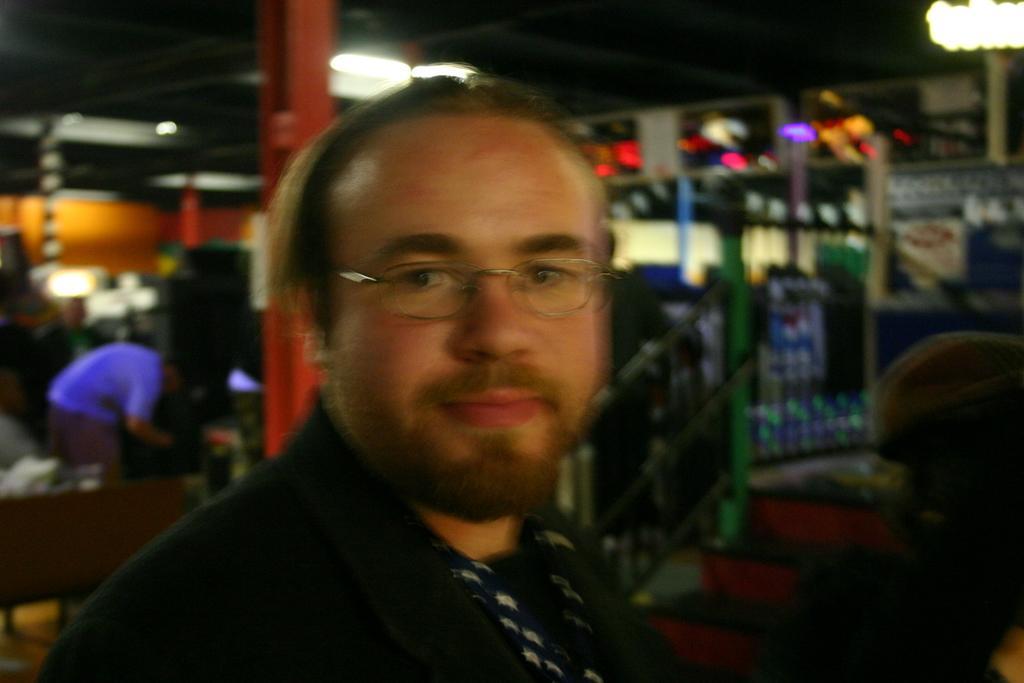How would you summarize this image in a sentence or two? In this image we can see a person wearing the spectacles, also we can see the pillars, lights, people and some other objects. 